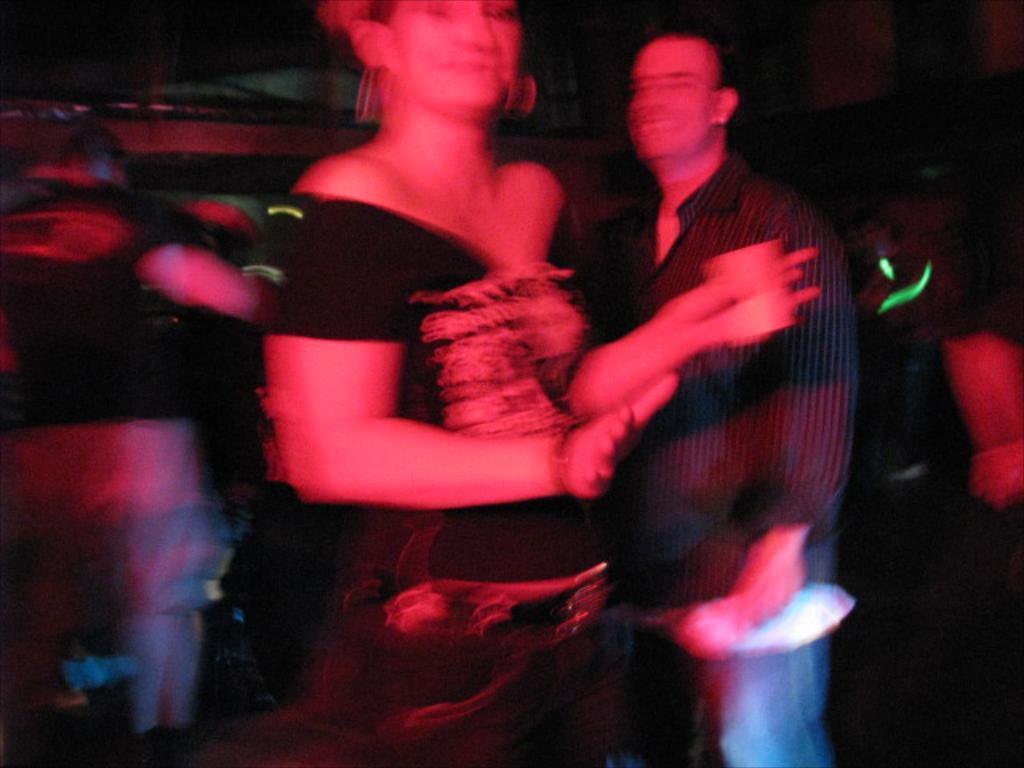Can you describe this image briefly? The image is blur but we can see few persons are standing. On the right a man is holding an object in his hand and a woman in the middle is holding a cup and and other objects in her hands. 